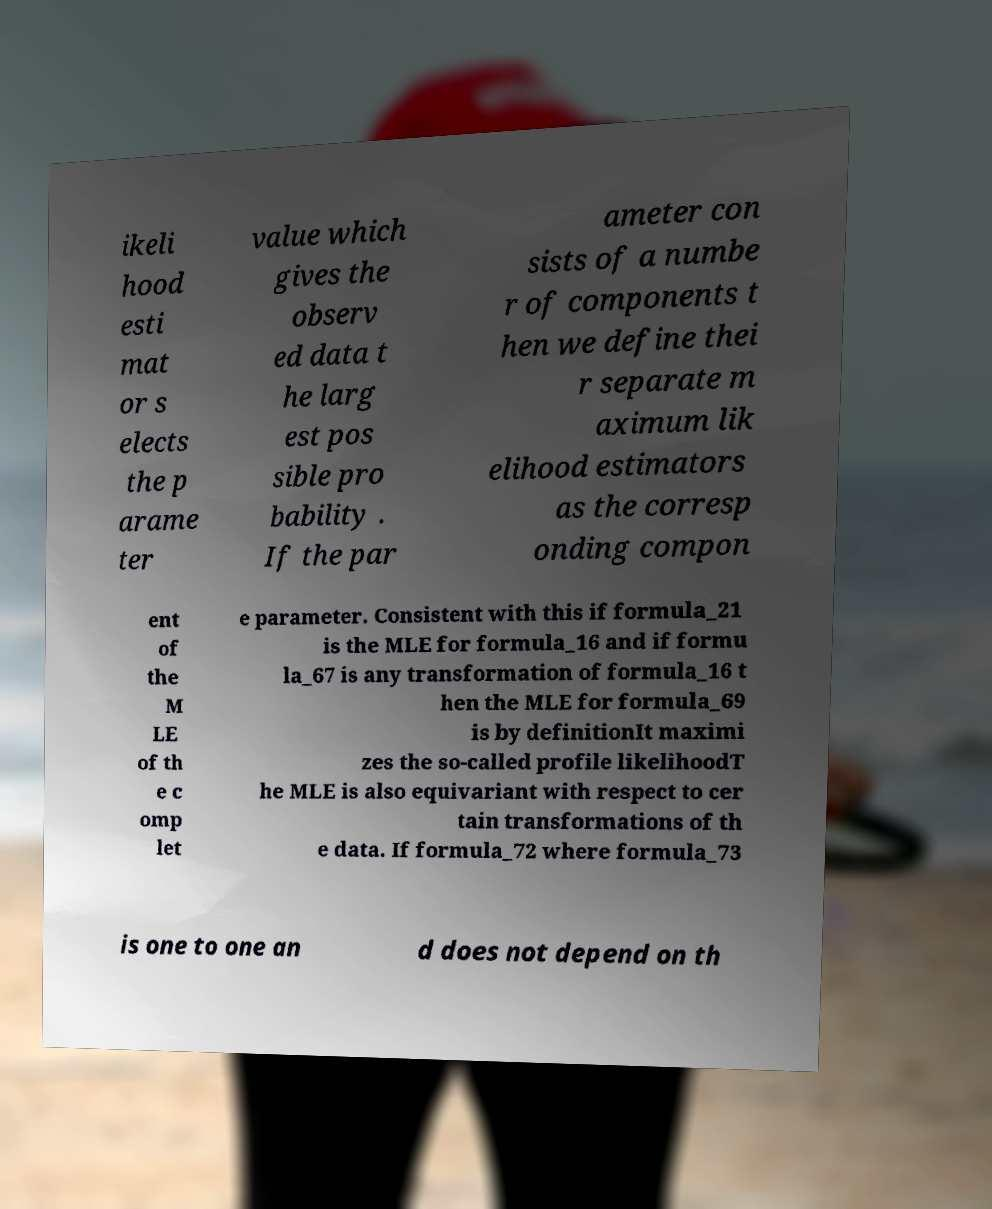There's text embedded in this image that I need extracted. Can you transcribe it verbatim? ikeli hood esti mat or s elects the p arame ter value which gives the observ ed data t he larg est pos sible pro bability . If the par ameter con sists of a numbe r of components t hen we define thei r separate m aximum lik elihood estimators as the corresp onding compon ent of the M LE of th e c omp let e parameter. Consistent with this if formula_21 is the MLE for formula_16 and if formu la_67 is any transformation of formula_16 t hen the MLE for formula_69 is by definitionIt maximi zes the so-called profile likelihoodT he MLE is also equivariant with respect to cer tain transformations of th e data. If formula_72 where formula_73 is one to one an d does not depend on th 